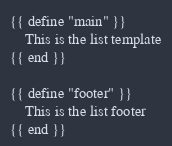<code> <loc_0><loc_0><loc_500><loc_500><_HTML_>{{ define "main" }}
	This is the list template
{{ end }}

{{ define "footer" }}
	This is the list footer
{{ end }}</code> 